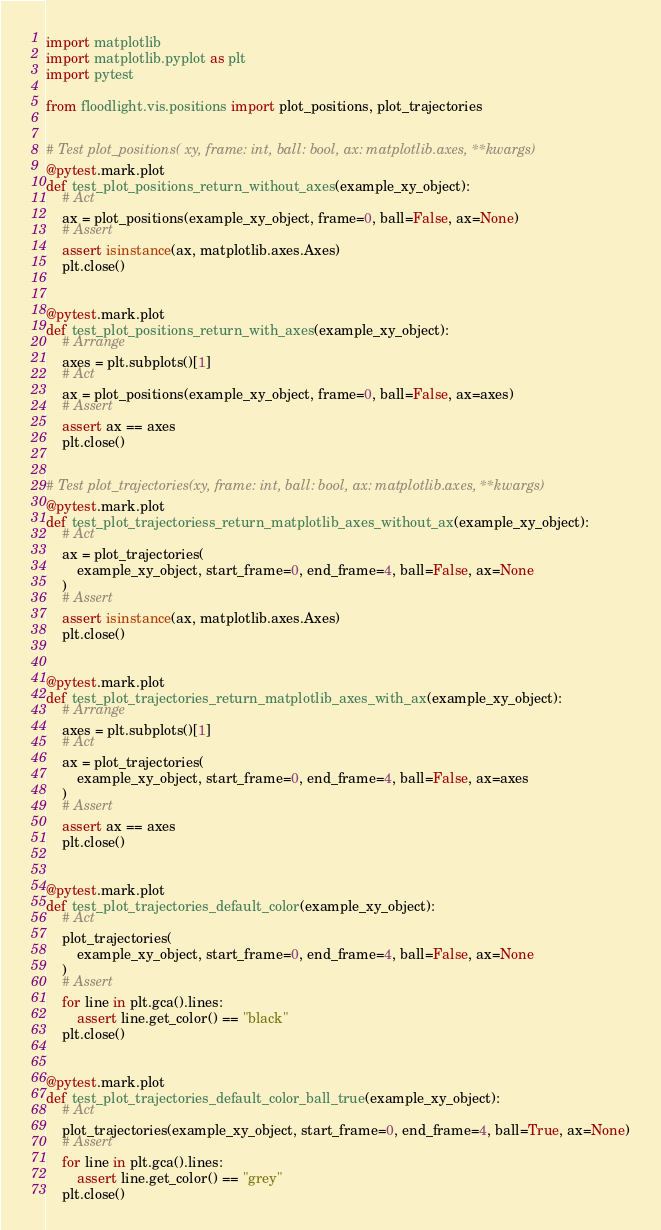<code> <loc_0><loc_0><loc_500><loc_500><_Python_>import matplotlib
import matplotlib.pyplot as plt
import pytest

from floodlight.vis.positions import plot_positions, plot_trajectories


# Test plot_positions( xy, frame: int, ball: bool, ax: matplotlib.axes, **kwargs)
@pytest.mark.plot
def test_plot_positions_return_without_axes(example_xy_object):
    # Act
    ax = plot_positions(example_xy_object, frame=0, ball=False, ax=None)
    # Assert
    assert isinstance(ax, matplotlib.axes.Axes)
    plt.close()


@pytest.mark.plot
def test_plot_positions_return_with_axes(example_xy_object):
    # Arrange
    axes = plt.subplots()[1]
    # Act
    ax = plot_positions(example_xy_object, frame=0, ball=False, ax=axes)
    # Assert
    assert ax == axes
    plt.close()


# Test plot_trajectories(xy, frame: int, ball: bool, ax: matplotlib.axes, **kwargs)
@pytest.mark.plot
def test_plot_trajectoriess_return_matplotlib_axes_without_ax(example_xy_object):
    # Act
    ax = plot_trajectories(
        example_xy_object, start_frame=0, end_frame=4, ball=False, ax=None
    )
    # Assert
    assert isinstance(ax, matplotlib.axes.Axes)
    plt.close()


@pytest.mark.plot
def test_plot_trajectories_return_matplotlib_axes_with_ax(example_xy_object):
    # Arrange
    axes = plt.subplots()[1]
    # Act
    ax = plot_trajectories(
        example_xy_object, start_frame=0, end_frame=4, ball=False, ax=axes
    )
    # Assert
    assert ax == axes
    plt.close()


@pytest.mark.plot
def test_plot_trajectories_default_color(example_xy_object):
    # Act
    plot_trajectories(
        example_xy_object, start_frame=0, end_frame=4, ball=False, ax=None
    )
    # Assert
    for line in plt.gca().lines:
        assert line.get_color() == "black"
    plt.close()


@pytest.mark.plot
def test_plot_trajectories_default_color_ball_true(example_xy_object):
    # Act
    plot_trajectories(example_xy_object, start_frame=0, end_frame=4, ball=True, ax=None)
    # Assert
    for line in plt.gca().lines:
        assert line.get_color() == "grey"
    plt.close()
</code> 